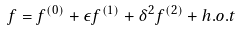<formula> <loc_0><loc_0><loc_500><loc_500>f = f ^ { ( 0 ) } + \epsilon f ^ { ( 1 ) } + \delta ^ { 2 } f ^ { ( 2 ) } + h . o . t</formula> 